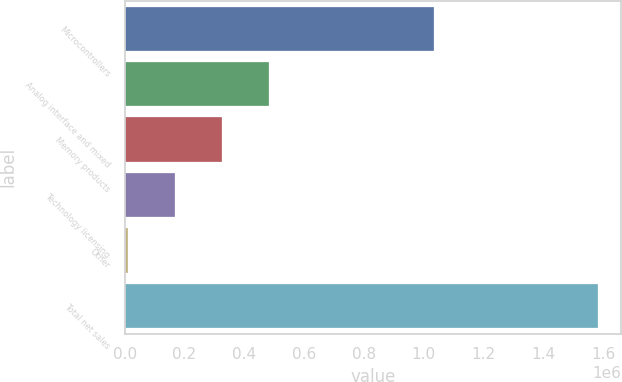<chart> <loc_0><loc_0><loc_500><loc_500><bar_chart><fcel>Microcontrollers<fcel>Analog interface and mixed<fcel>Memory products<fcel>Technology licensing<fcel>Other<fcel>Total net sales<nl><fcel>1.03551e+06<fcel>482905<fcel>325945<fcel>168986<fcel>12026<fcel>1.58162e+06<nl></chart> 